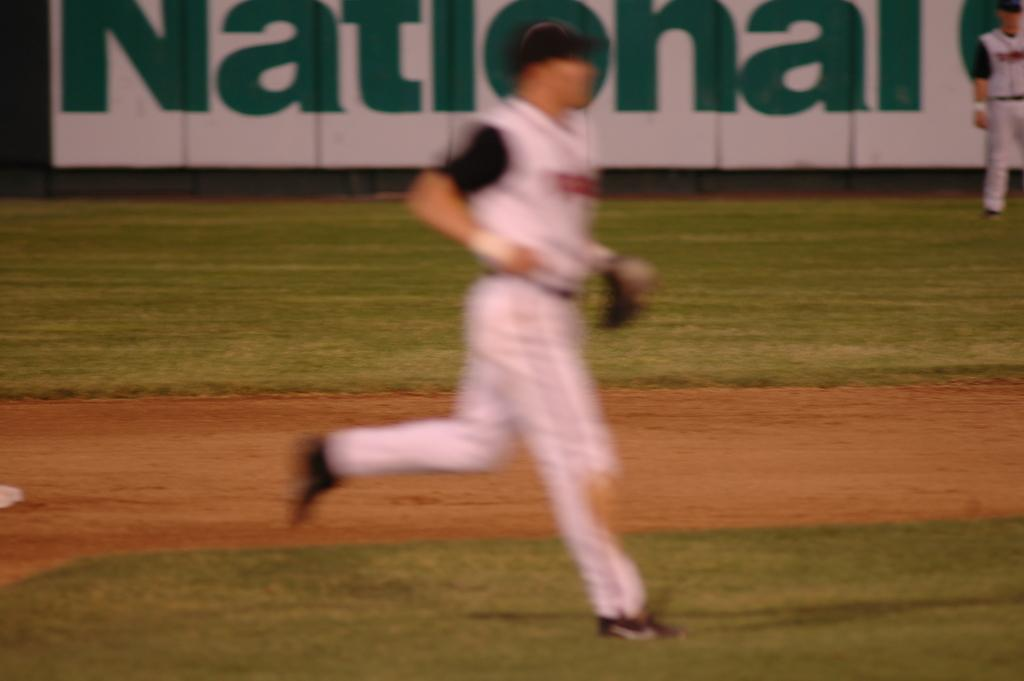<image>
Write a terse but informative summary of the picture. View of a stadium with a player and a placard saying National, the picture is very blur. 